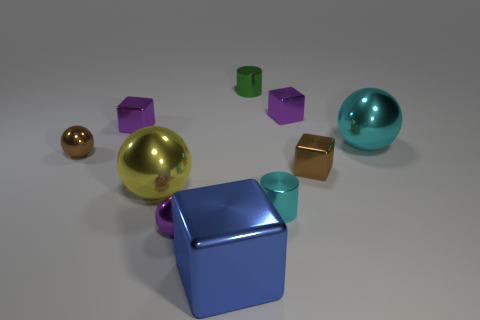Subtract all cubes. How many objects are left? 6 Subtract 0 red cylinders. How many objects are left? 10 Subtract all small blocks. Subtract all spheres. How many objects are left? 3 Add 3 cyan shiny cylinders. How many cyan shiny cylinders are left? 4 Add 1 yellow metallic objects. How many yellow metallic objects exist? 2 